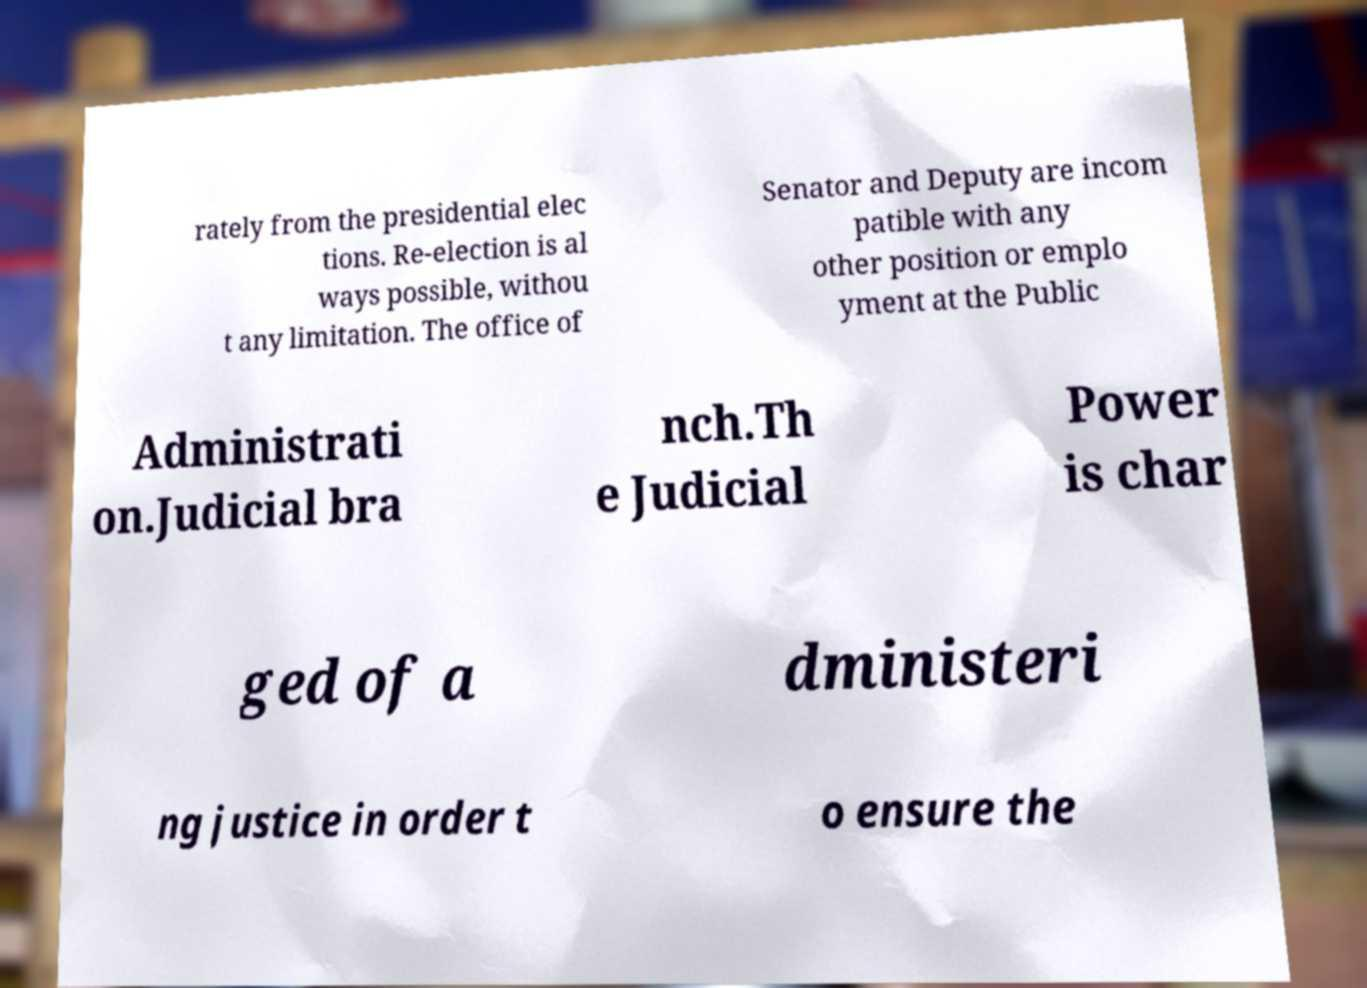There's text embedded in this image that I need extracted. Can you transcribe it verbatim? rately from the presidential elec tions. Re-election is al ways possible, withou t any limitation. The office of Senator and Deputy are incom patible with any other position or emplo yment at the Public Administrati on.Judicial bra nch.Th e Judicial Power is char ged of a dministeri ng justice in order t o ensure the 